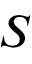Convert formula to latex. <formula><loc_0><loc_0><loc_500><loc_500>S</formula> 